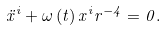Convert formula to latex. <formula><loc_0><loc_0><loc_500><loc_500>\ddot { x } ^ { i } + \omega \left ( t \right ) x ^ { i } r ^ { - 4 } = 0 .</formula> 